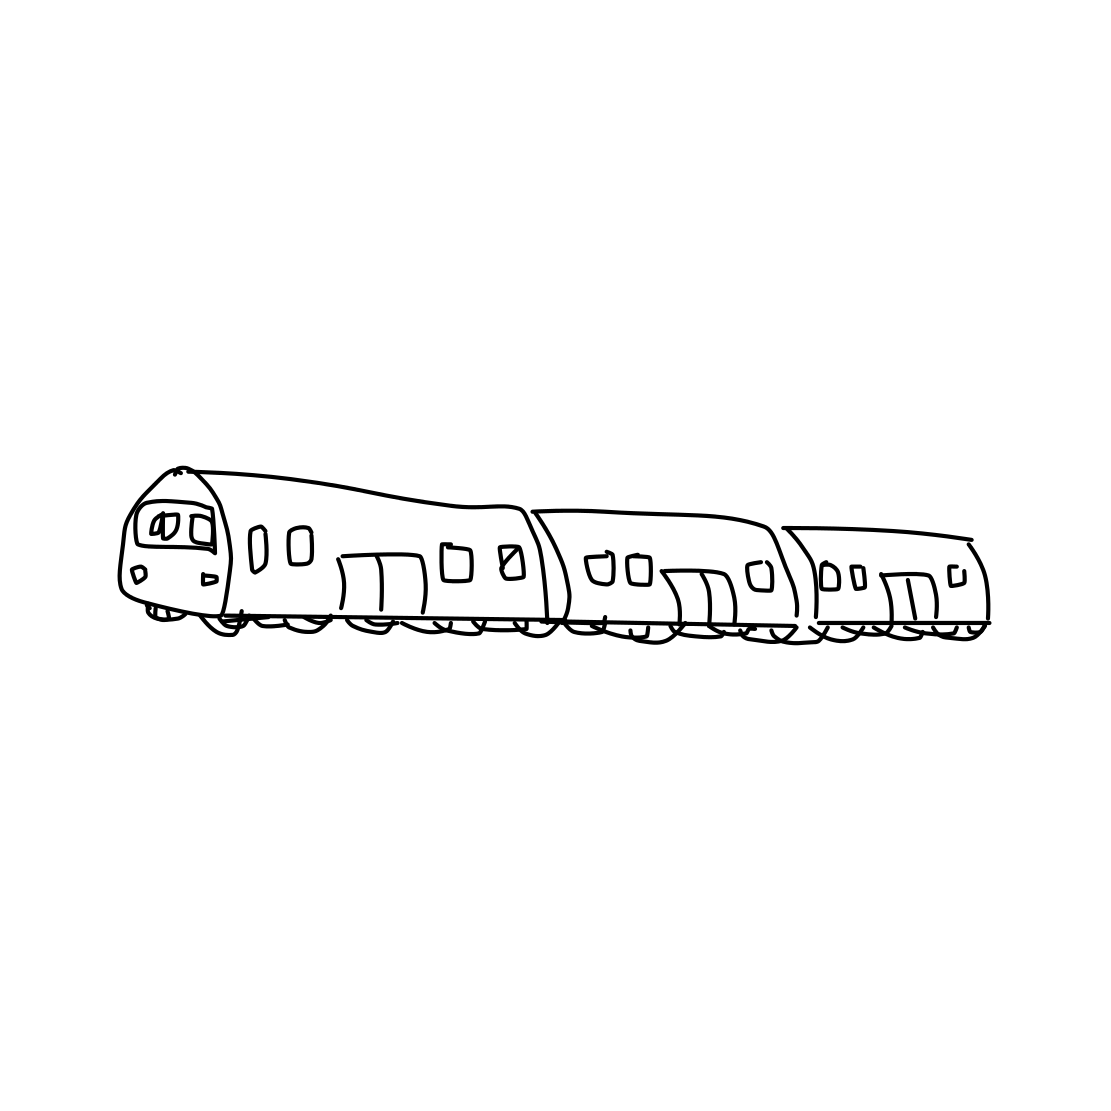Could you describe the style of the drawing? Certainly, the drawing is done in a line art style, utilizing clean, uncomplicated lines without shading or color which gives it a minimalistic and modern feel. It captures the train's form through outline and simple internal detailing, making it clear and easily recognizable. 